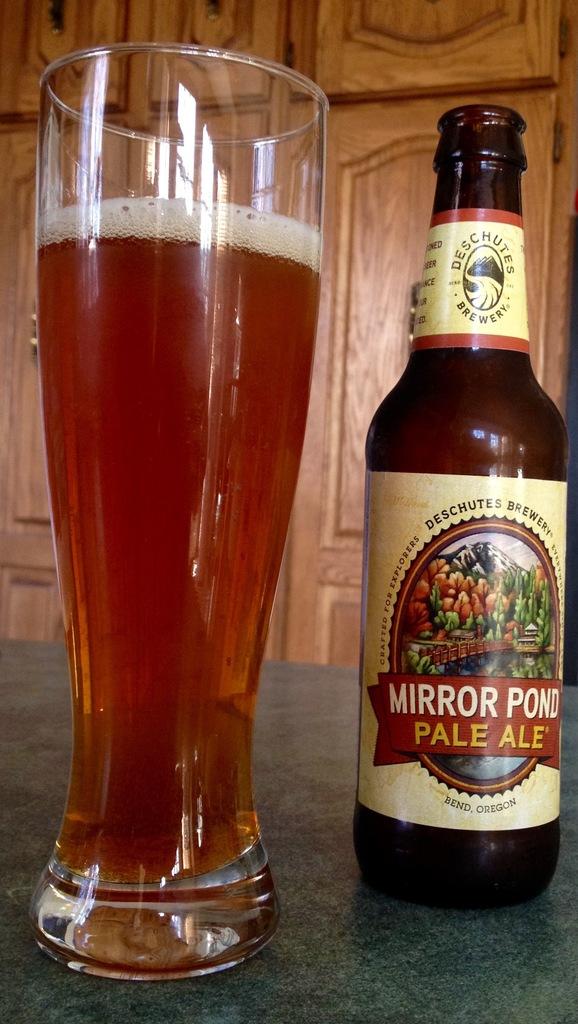How does the label describe this ale?
Your response must be concise. Pale. 